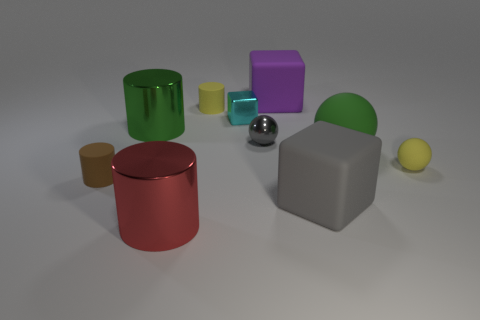Subtract all cubes. How many objects are left? 7 Subtract all small yellow metallic things. Subtract all small gray balls. How many objects are left? 9 Add 3 tiny cyan objects. How many tiny cyan objects are left? 4 Add 8 cyan cubes. How many cyan cubes exist? 9 Subtract 0 gray cylinders. How many objects are left? 10 